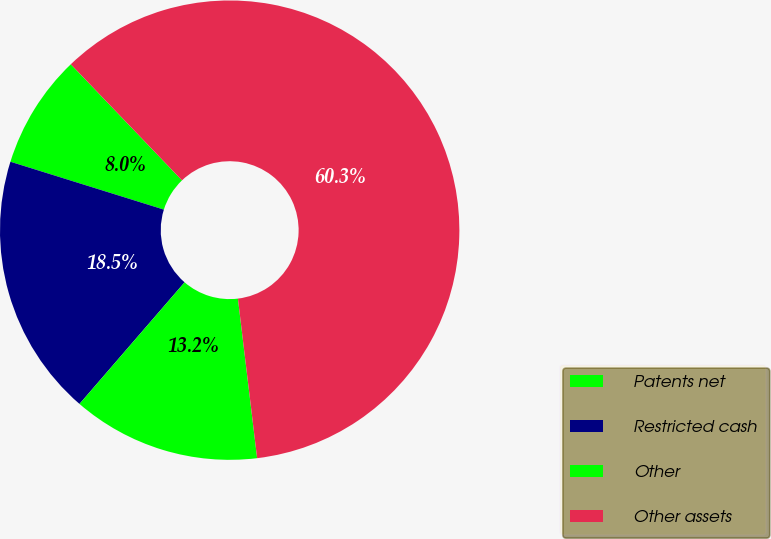Convert chart. <chart><loc_0><loc_0><loc_500><loc_500><pie_chart><fcel>Patents net<fcel>Restricted cash<fcel>Other<fcel>Other assets<nl><fcel>8.03%<fcel>18.47%<fcel>13.25%<fcel>60.25%<nl></chart> 